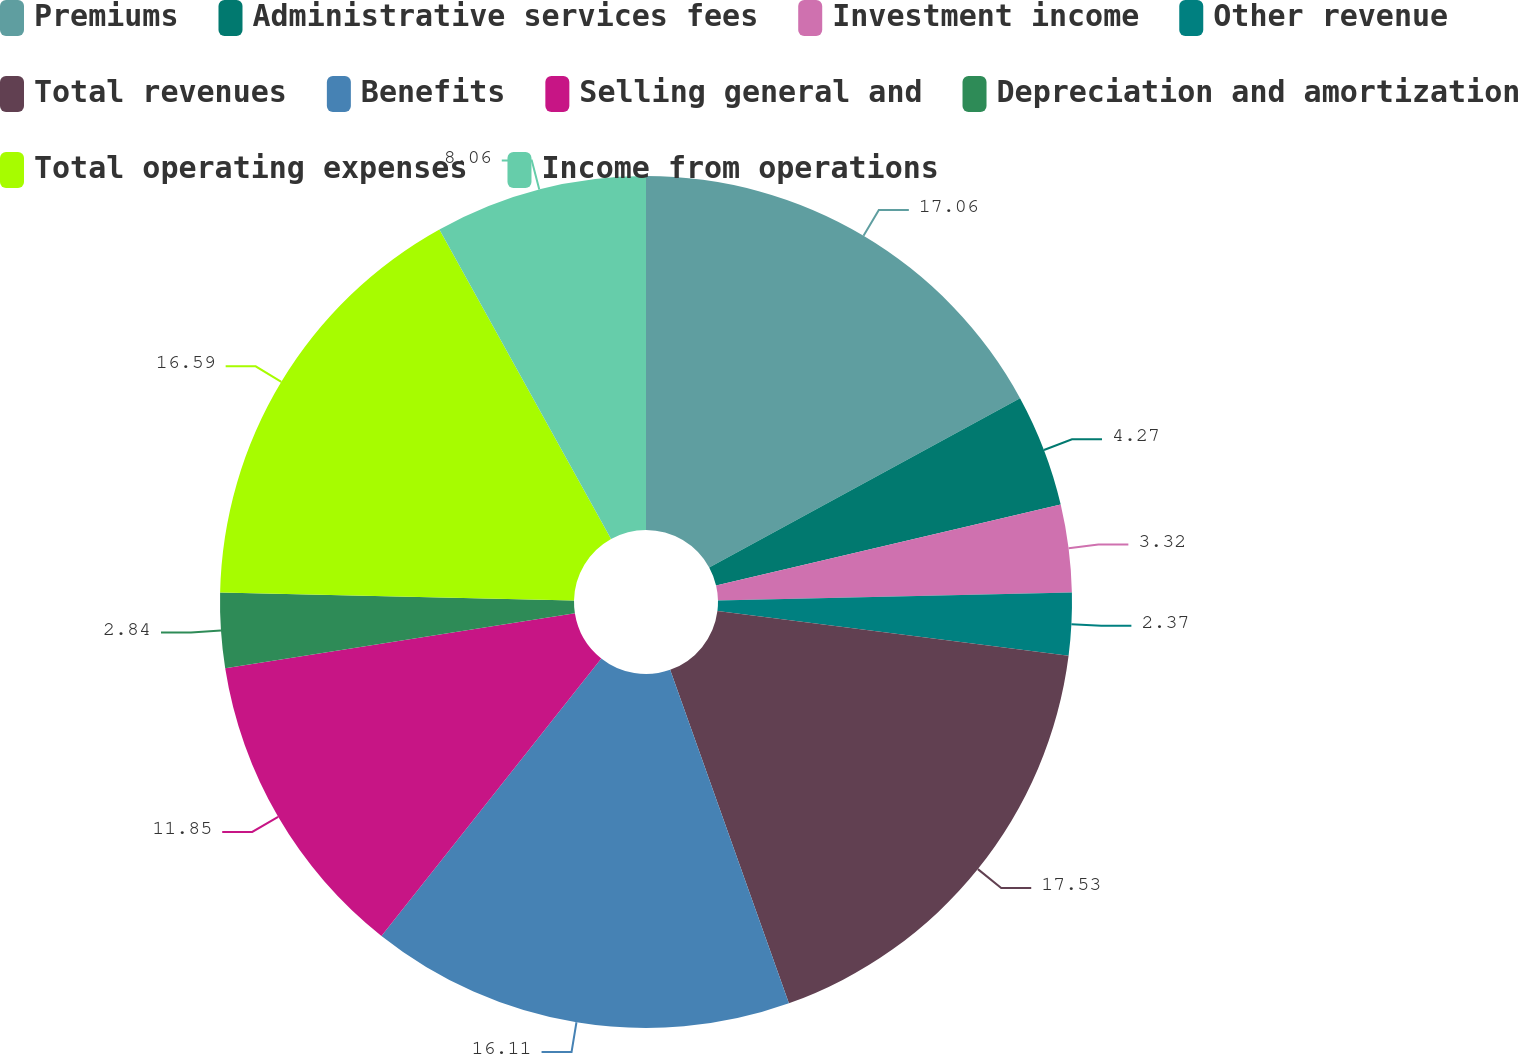Convert chart. <chart><loc_0><loc_0><loc_500><loc_500><pie_chart><fcel>Premiums<fcel>Administrative services fees<fcel>Investment income<fcel>Other revenue<fcel>Total revenues<fcel>Benefits<fcel>Selling general and<fcel>Depreciation and amortization<fcel>Total operating expenses<fcel>Income from operations<nl><fcel>17.06%<fcel>4.27%<fcel>3.32%<fcel>2.37%<fcel>17.54%<fcel>16.11%<fcel>11.85%<fcel>2.84%<fcel>16.59%<fcel>8.06%<nl></chart> 